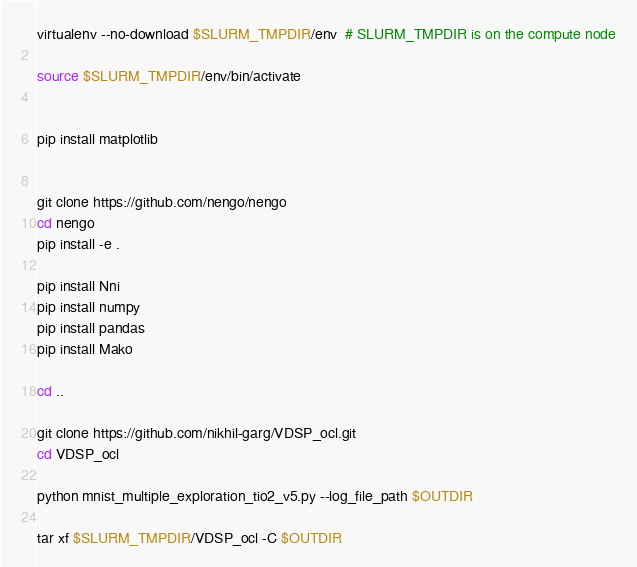<code> <loc_0><loc_0><loc_500><loc_500><_Bash_>
virtualenv --no-download $SLURM_TMPDIR/env  # SLURM_TMPDIR is on the compute node

source $SLURM_TMPDIR/env/bin/activate


pip install matplotlib


git clone https://github.com/nengo/nengo
cd nengo
pip install -e .

pip install Nni
pip install numpy
pip install pandas
pip install Mako

cd ..

git clone https://github.com/nikhil-garg/VDSP_ocl.git
cd VDSP_ocl

python mnist_multiple_exploration_tio2_v5.py --log_file_path $OUTDIR

tar xf $SLURM_TMPDIR/VDSP_ocl -C $OUTDIR
</code> 